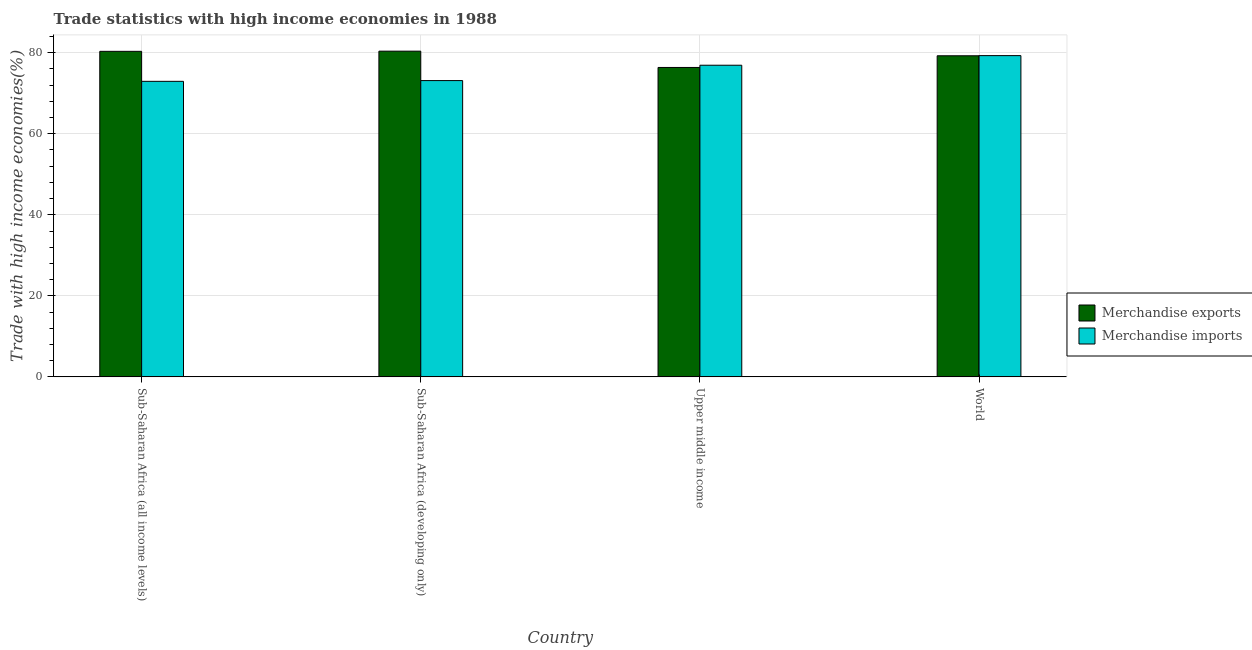How many different coloured bars are there?
Your answer should be very brief. 2. How many groups of bars are there?
Your answer should be compact. 4. Are the number of bars per tick equal to the number of legend labels?
Provide a short and direct response. Yes. How many bars are there on the 2nd tick from the right?
Keep it short and to the point. 2. What is the label of the 2nd group of bars from the left?
Offer a terse response. Sub-Saharan Africa (developing only). What is the merchandise exports in Sub-Saharan Africa (developing only)?
Your response must be concise. 80.39. Across all countries, what is the maximum merchandise exports?
Your answer should be compact. 80.39. Across all countries, what is the minimum merchandise exports?
Your response must be concise. 76.37. In which country was the merchandise exports maximum?
Give a very brief answer. Sub-Saharan Africa (developing only). In which country was the merchandise imports minimum?
Your answer should be compact. Sub-Saharan Africa (all income levels). What is the total merchandise imports in the graph?
Make the answer very short. 302.29. What is the difference between the merchandise imports in Sub-Saharan Africa (all income levels) and that in Sub-Saharan Africa (developing only)?
Keep it short and to the point. -0.18. What is the difference between the merchandise exports in Sub-Saharan Africa (all income levels) and the merchandise imports in Sub-Saharan Africa (developing only)?
Give a very brief answer. 7.22. What is the average merchandise imports per country?
Provide a succinct answer. 75.57. What is the difference between the merchandise imports and merchandise exports in Upper middle income?
Keep it short and to the point. 0.55. What is the ratio of the merchandise imports in Sub-Saharan Africa (all income levels) to that in World?
Offer a terse response. 0.92. Is the merchandise imports in Sub-Saharan Africa (developing only) less than that in World?
Offer a terse response. Yes. Is the difference between the merchandise imports in Upper middle income and World greater than the difference between the merchandise exports in Upper middle income and World?
Offer a terse response. Yes. What is the difference between the highest and the second highest merchandise imports?
Provide a succinct answer. 2.37. What is the difference between the highest and the lowest merchandise exports?
Provide a succinct answer. 4.02. In how many countries, is the merchandise exports greater than the average merchandise exports taken over all countries?
Your answer should be very brief. 3. How many bars are there?
Your answer should be compact. 8. Are all the bars in the graph horizontal?
Keep it short and to the point. No. How many countries are there in the graph?
Provide a succinct answer. 4. What is the difference between two consecutive major ticks on the Y-axis?
Keep it short and to the point. 20. Are the values on the major ticks of Y-axis written in scientific E-notation?
Make the answer very short. No. Where does the legend appear in the graph?
Provide a short and direct response. Center right. How are the legend labels stacked?
Your answer should be compact. Vertical. What is the title of the graph?
Provide a succinct answer. Trade statistics with high income economies in 1988. Does "Canada" appear as one of the legend labels in the graph?
Give a very brief answer. No. What is the label or title of the X-axis?
Offer a terse response. Country. What is the label or title of the Y-axis?
Make the answer very short. Trade with high income economies(%). What is the Trade with high income economies(%) in Merchandise exports in Sub-Saharan Africa (all income levels)?
Offer a terse response. 80.35. What is the Trade with high income economies(%) in Merchandise imports in Sub-Saharan Africa (all income levels)?
Give a very brief answer. 72.95. What is the Trade with high income economies(%) in Merchandise exports in Sub-Saharan Africa (developing only)?
Your response must be concise. 80.39. What is the Trade with high income economies(%) of Merchandise imports in Sub-Saharan Africa (developing only)?
Make the answer very short. 73.13. What is the Trade with high income economies(%) in Merchandise exports in Upper middle income?
Provide a short and direct response. 76.37. What is the Trade with high income economies(%) of Merchandise imports in Upper middle income?
Make the answer very short. 76.92. What is the Trade with high income economies(%) in Merchandise exports in World?
Offer a terse response. 79.25. What is the Trade with high income economies(%) of Merchandise imports in World?
Offer a terse response. 79.29. Across all countries, what is the maximum Trade with high income economies(%) of Merchandise exports?
Give a very brief answer. 80.39. Across all countries, what is the maximum Trade with high income economies(%) of Merchandise imports?
Make the answer very short. 79.29. Across all countries, what is the minimum Trade with high income economies(%) of Merchandise exports?
Offer a very short reply. 76.37. Across all countries, what is the minimum Trade with high income economies(%) in Merchandise imports?
Ensure brevity in your answer.  72.95. What is the total Trade with high income economies(%) in Merchandise exports in the graph?
Provide a short and direct response. 316.37. What is the total Trade with high income economies(%) in Merchandise imports in the graph?
Make the answer very short. 302.29. What is the difference between the Trade with high income economies(%) of Merchandise exports in Sub-Saharan Africa (all income levels) and that in Sub-Saharan Africa (developing only)?
Keep it short and to the point. -0.04. What is the difference between the Trade with high income economies(%) in Merchandise imports in Sub-Saharan Africa (all income levels) and that in Sub-Saharan Africa (developing only)?
Your answer should be very brief. -0.18. What is the difference between the Trade with high income economies(%) in Merchandise exports in Sub-Saharan Africa (all income levels) and that in Upper middle income?
Your response must be concise. 3.98. What is the difference between the Trade with high income economies(%) of Merchandise imports in Sub-Saharan Africa (all income levels) and that in Upper middle income?
Provide a short and direct response. -3.97. What is the difference between the Trade with high income economies(%) in Merchandise exports in Sub-Saharan Africa (all income levels) and that in World?
Provide a short and direct response. 1.1. What is the difference between the Trade with high income economies(%) of Merchandise imports in Sub-Saharan Africa (all income levels) and that in World?
Your answer should be compact. -6.35. What is the difference between the Trade with high income economies(%) in Merchandise exports in Sub-Saharan Africa (developing only) and that in Upper middle income?
Make the answer very short. 4.02. What is the difference between the Trade with high income economies(%) in Merchandise imports in Sub-Saharan Africa (developing only) and that in Upper middle income?
Offer a terse response. -3.79. What is the difference between the Trade with high income economies(%) in Merchandise exports in Sub-Saharan Africa (developing only) and that in World?
Offer a terse response. 1.14. What is the difference between the Trade with high income economies(%) in Merchandise imports in Sub-Saharan Africa (developing only) and that in World?
Your response must be concise. -6.16. What is the difference between the Trade with high income economies(%) in Merchandise exports in Upper middle income and that in World?
Ensure brevity in your answer.  -2.88. What is the difference between the Trade with high income economies(%) of Merchandise imports in Upper middle income and that in World?
Your response must be concise. -2.37. What is the difference between the Trade with high income economies(%) of Merchandise exports in Sub-Saharan Africa (all income levels) and the Trade with high income economies(%) of Merchandise imports in Sub-Saharan Africa (developing only)?
Provide a succinct answer. 7.22. What is the difference between the Trade with high income economies(%) in Merchandise exports in Sub-Saharan Africa (all income levels) and the Trade with high income economies(%) in Merchandise imports in Upper middle income?
Provide a succinct answer. 3.43. What is the difference between the Trade with high income economies(%) of Merchandise exports in Sub-Saharan Africa (all income levels) and the Trade with high income economies(%) of Merchandise imports in World?
Keep it short and to the point. 1.06. What is the difference between the Trade with high income economies(%) of Merchandise exports in Sub-Saharan Africa (developing only) and the Trade with high income economies(%) of Merchandise imports in Upper middle income?
Provide a succinct answer. 3.47. What is the difference between the Trade with high income economies(%) of Merchandise exports in Sub-Saharan Africa (developing only) and the Trade with high income economies(%) of Merchandise imports in World?
Keep it short and to the point. 1.1. What is the difference between the Trade with high income economies(%) of Merchandise exports in Upper middle income and the Trade with high income economies(%) of Merchandise imports in World?
Provide a succinct answer. -2.92. What is the average Trade with high income economies(%) in Merchandise exports per country?
Provide a succinct answer. 79.09. What is the average Trade with high income economies(%) in Merchandise imports per country?
Your response must be concise. 75.57. What is the difference between the Trade with high income economies(%) of Merchandise exports and Trade with high income economies(%) of Merchandise imports in Sub-Saharan Africa (all income levels)?
Give a very brief answer. 7.4. What is the difference between the Trade with high income economies(%) of Merchandise exports and Trade with high income economies(%) of Merchandise imports in Sub-Saharan Africa (developing only)?
Provide a succinct answer. 7.26. What is the difference between the Trade with high income economies(%) of Merchandise exports and Trade with high income economies(%) of Merchandise imports in Upper middle income?
Your answer should be compact. -0.55. What is the difference between the Trade with high income economies(%) of Merchandise exports and Trade with high income economies(%) of Merchandise imports in World?
Keep it short and to the point. -0.04. What is the ratio of the Trade with high income economies(%) in Merchandise imports in Sub-Saharan Africa (all income levels) to that in Sub-Saharan Africa (developing only)?
Ensure brevity in your answer.  1. What is the ratio of the Trade with high income economies(%) in Merchandise exports in Sub-Saharan Africa (all income levels) to that in Upper middle income?
Offer a terse response. 1.05. What is the ratio of the Trade with high income economies(%) in Merchandise imports in Sub-Saharan Africa (all income levels) to that in Upper middle income?
Give a very brief answer. 0.95. What is the ratio of the Trade with high income economies(%) of Merchandise exports in Sub-Saharan Africa (all income levels) to that in World?
Your answer should be very brief. 1.01. What is the ratio of the Trade with high income economies(%) of Merchandise imports in Sub-Saharan Africa (all income levels) to that in World?
Provide a short and direct response. 0.92. What is the ratio of the Trade with high income economies(%) in Merchandise exports in Sub-Saharan Africa (developing only) to that in Upper middle income?
Give a very brief answer. 1.05. What is the ratio of the Trade with high income economies(%) of Merchandise imports in Sub-Saharan Africa (developing only) to that in Upper middle income?
Ensure brevity in your answer.  0.95. What is the ratio of the Trade with high income economies(%) in Merchandise exports in Sub-Saharan Africa (developing only) to that in World?
Provide a succinct answer. 1.01. What is the ratio of the Trade with high income economies(%) of Merchandise imports in Sub-Saharan Africa (developing only) to that in World?
Keep it short and to the point. 0.92. What is the ratio of the Trade with high income economies(%) of Merchandise exports in Upper middle income to that in World?
Your answer should be compact. 0.96. What is the ratio of the Trade with high income economies(%) in Merchandise imports in Upper middle income to that in World?
Make the answer very short. 0.97. What is the difference between the highest and the second highest Trade with high income economies(%) of Merchandise exports?
Ensure brevity in your answer.  0.04. What is the difference between the highest and the second highest Trade with high income economies(%) of Merchandise imports?
Your answer should be compact. 2.37. What is the difference between the highest and the lowest Trade with high income economies(%) of Merchandise exports?
Ensure brevity in your answer.  4.02. What is the difference between the highest and the lowest Trade with high income economies(%) of Merchandise imports?
Your answer should be very brief. 6.35. 